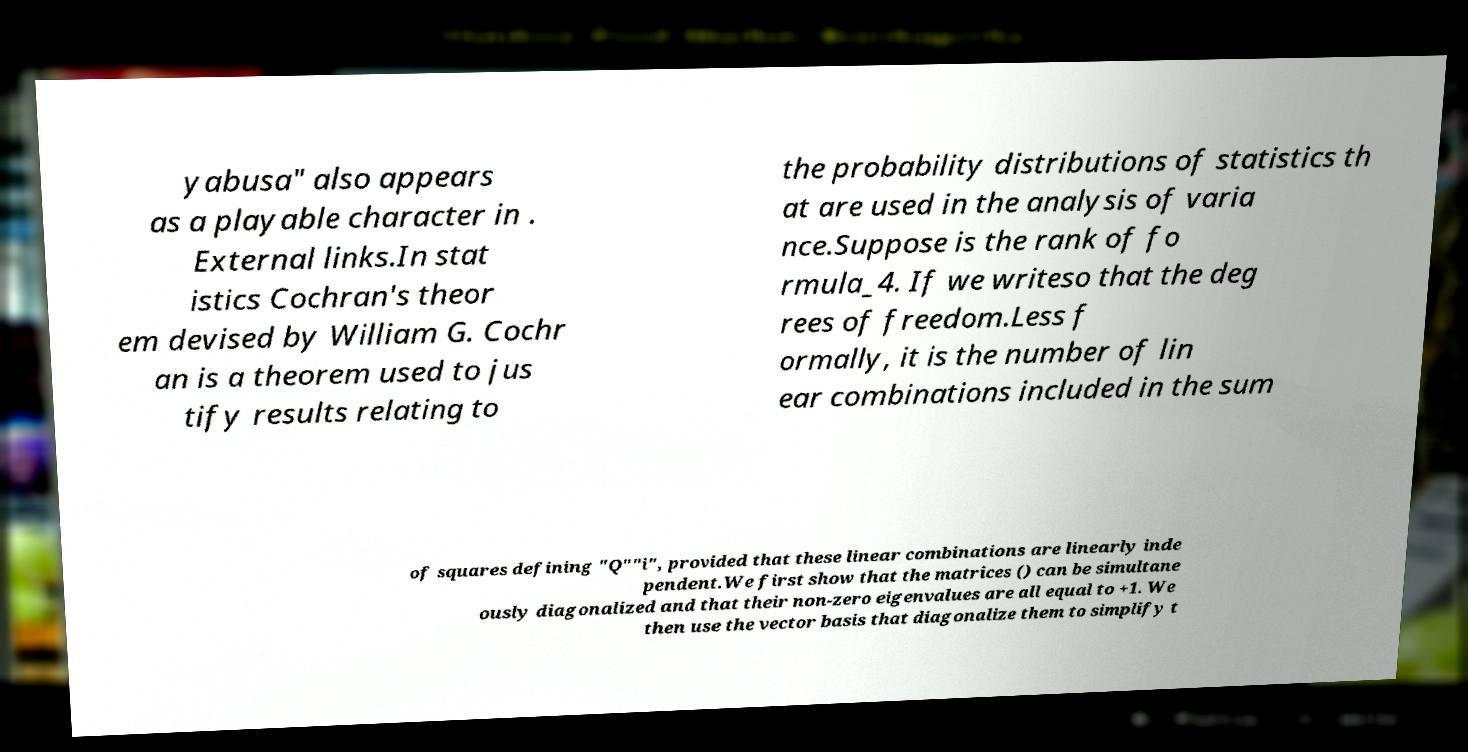Could you extract and type out the text from this image? yabusa" also appears as a playable character in . External links.In stat istics Cochran's theor em devised by William G. Cochr an is a theorem used to jus tify results relating to the probability distributions of statistics th at are used in the analysis of varia nce.Suppose is the rank of fo rmula_4. If we writeso that the deg rees of freedom.Less f ormally, it is the number of lin ear combinations included in the sum of squares defining "Q""i", provided that these linear combinations are linearly inde pendent.We first show that the matrices () can be simultane ously diagonalized and that their non-zero eigenvalues are all equal to +1. We then use the vector basis that diagonalize them to simplify t 